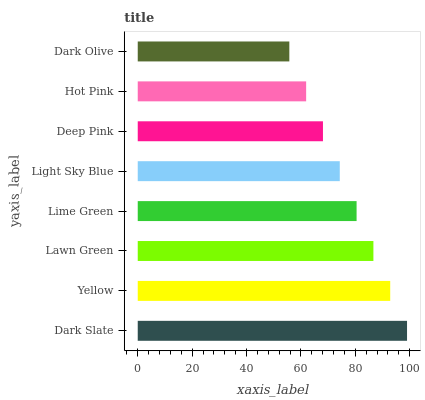Is Dark Olive the minimum?
Answer yes or no. Yes. Is Dark Slate the maximum?
Answer yes or no. Yes. Is Yellow the minimum?
Answer yes or no. No. Is Yellow the maximum?
Answer yes or no. No. Is Dark Slate greater than Yellow?
Answer yes or no. Yes. Is Yellow less than Dark Slate?
Answer yes or no. Yes. Is Yellow greater than Dark Slate?
Answer yes or no. No. Is Dark Slate less than Yellow?
Answer yes or no. No. Is Lime Green the high median?
Answer yes or no. Yes. Is Light Sky Blue the low median?
Answer yes or no. Yes. Is Lawn Green the high median?
Answer yes or no. No. Is Dark Slate the low median?
Answer yes or no. No. 